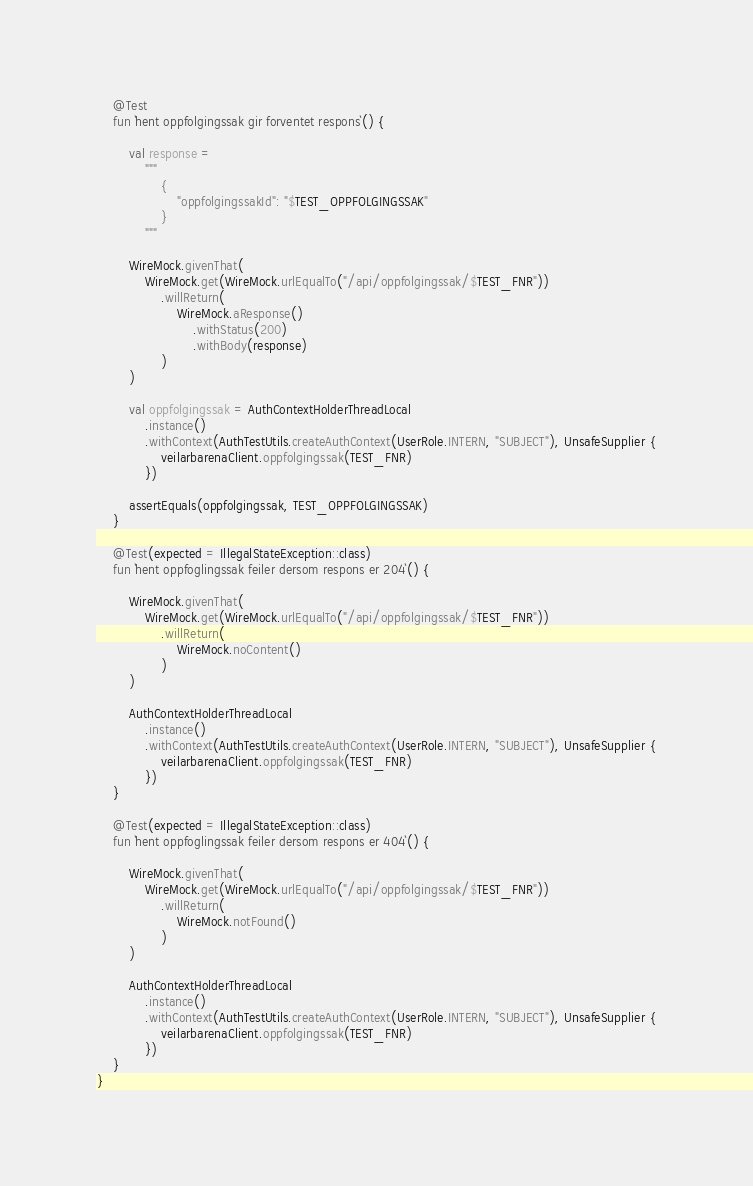<code> <loc_0><loc_0><loc_500><loc_500><_Kotlin_>
    @Test
    fun `hent oppfolgingssak gir forventet respons`() {

        val response =
            """
                {
                    "oppfolgingssakId": "$TEST_OPPFOLGINGSSAK"
                } 
            """

        WireMock.givenThat(
            WireMock.get(WireMock.urlEqualTo("/api/oppfolgingssak/$TEST_FNR"))
                .willReturn(
                    WireMock.aResponse()
                        .withStatus(200)
                        .withBody(response)
                )
        )

        val oppfolgingssak = AuthContextHolderThreadLocal
            .instance()
            .withContext(AuthTestUtils.createAuthContext(UserRole.INTERN, "SUBJECT"), UnsafeSupplier {
                veilarbarenaClient.oppfolgingssak(TEST_FNR)
            })

        assertEquals(oppfolgingssak, TEST_OPPFOLGINGSSAK)
    }

    @Test(expected = IllegalStateException::class)
    fun `hent oppfoglingssak feiler dersom respons er 204`() {

        WireMock.givenThat(
            WireMock.get(WireMock.urlEqualTo("/api/oppfolgingssak/$TEST_FNR"))
                .willReturn(
                    WireMock.noContent()
                )
        )

        AuthContextHolderThreadLocal
            .instance()
            .withContext(AuthTestUtils.createAuthContext(UserRole.INTERN, "SUBJECT"), UnsafeSupplier {
                veilarbarenaClient.oppfolgingssak(TEST_FNR)
            })
    }

    @Test(expected = IllegalStateException::class)
    fun `hent oppfoglingssak feiler dersom respons er 404`() {

        WireMock.givenThat(
            WireMock.get(WireMock.urlEqualTo("/api/oppfolgingssak/$TEST_FNR"))
                .willReturn(
                    WireMock.notFound()
                )
        )

        AuthContextHolderThreadLocal
            .instance()
            .withContext(AuthTestUtils.createAuthContext(UserRole.INTERN, "SUBJECT"), UnsafeSupplier {
                veilarbarenaClient.oppfolgingssak(TEST_FNR)
            })
    }
}
</code> 